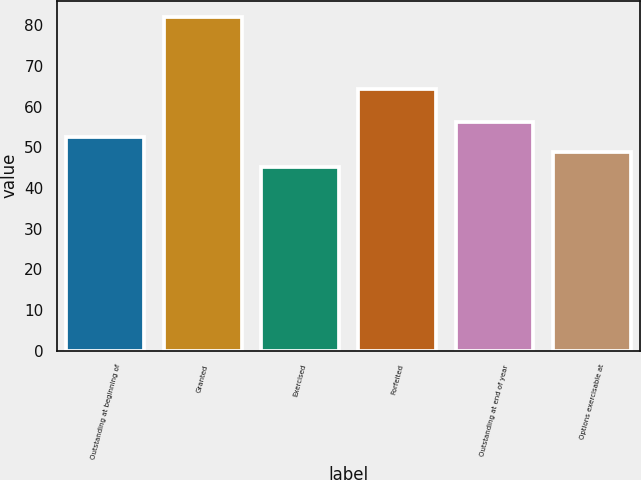Convert chart to OTSL. <chart><loc_0><loc_0><loc_500><loc_500><bar_chart><fcel>Outstanding at beginning of<fcel>Granted<fcel>Exercised<fcel>Forfeited<fcel>Outstanding at end of year<fcel>Options exercisable at<nl><fcel>52.59<fcel>81.95<fcel>45.25<fcel>64.38<fcel>56.26<fcel>48.92<nl></chart> 